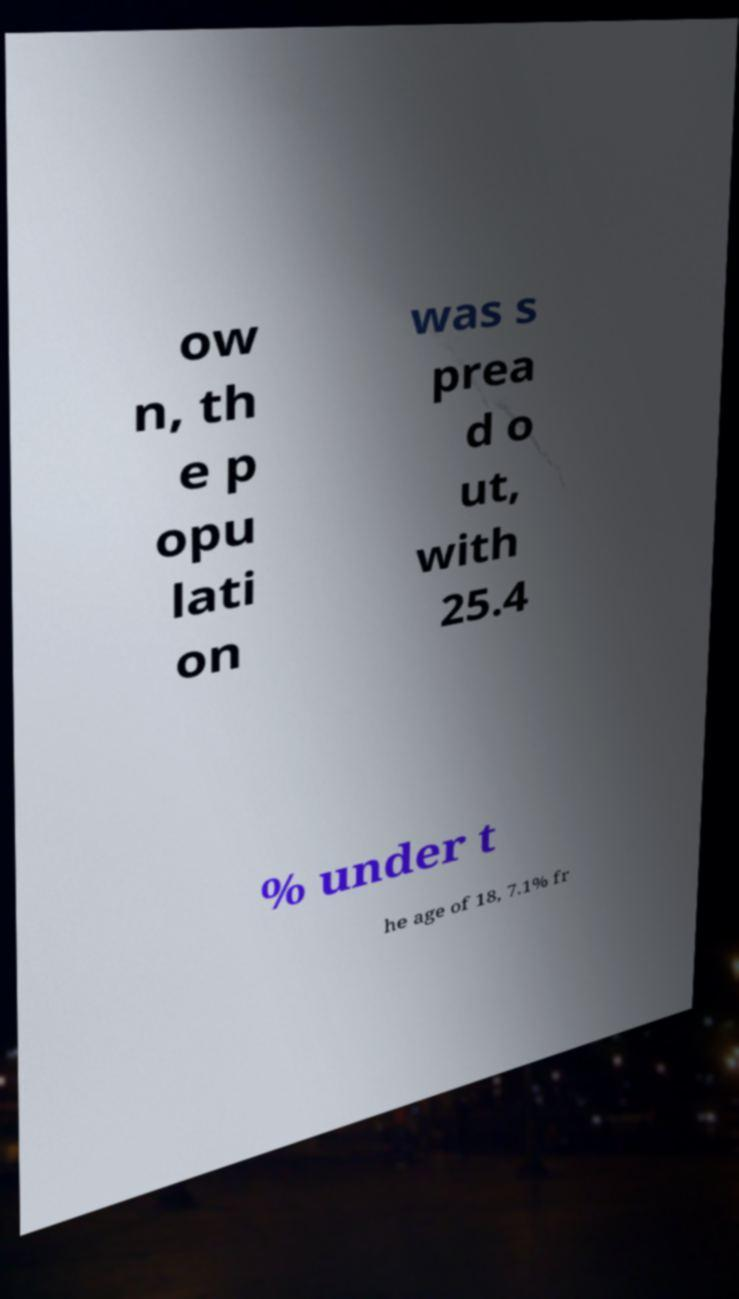Can you read and provide the text displayed in the image?This photo seems to have some interesting text. Can you extract and type it out for me? ow n, th e p opu lati on was s prea d o ut, with 25.4 % under t he age of 18, 7.1% fr 